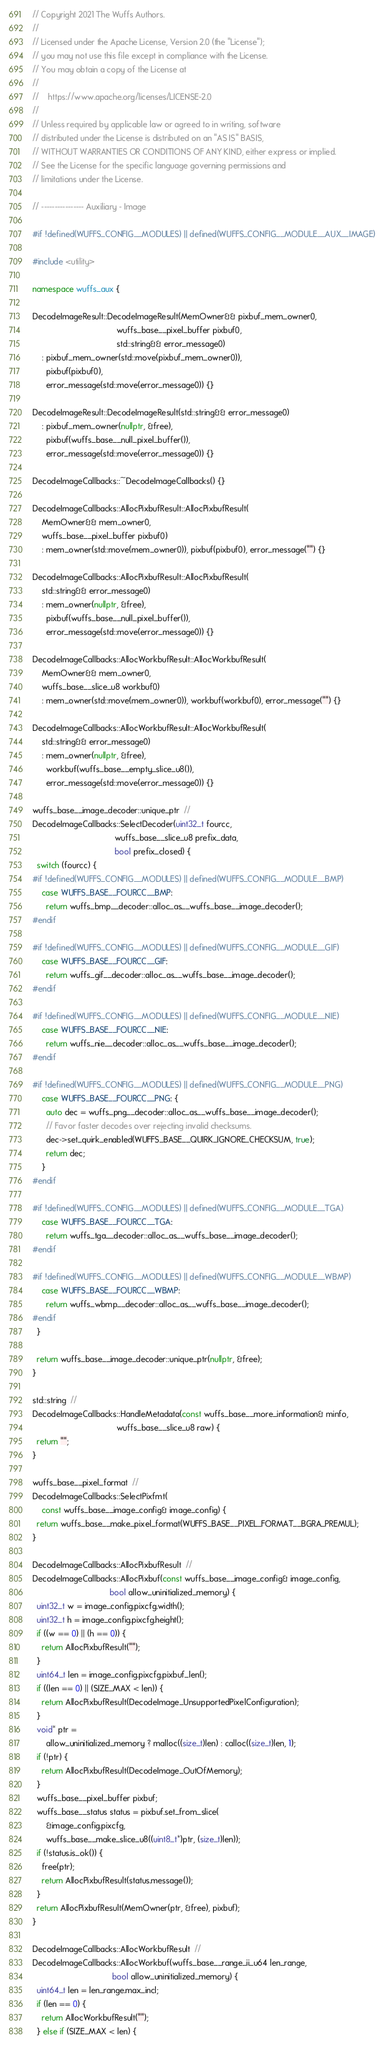<code> <loc_0><loc_0><loc_500><loc_500><_C++_>// Copyright 2021 The Wuffs Authors.
//
// Licensed under the Apache License, Version 2.0 (the "License");
// you may not use this file except in compliance with the License.
// You may obtain a copy of the License at
//
//    https://www.apache.org/licenses/LICENSE-2.0
//
// Unless required by applicable law or agreed to in writing, software
// distributed under the License is distributed on an "AS IS" BASIS,
// WITHOUT WARRANTIES OR CONDITIONS OF ANY KIND, either express or implied.
// See the License for the specific language governing permissions and
// limitations under the License.

// ---------------- Auxiliary - Image

#if !defined(WUFFS_CONFIG__MODULES) || defined(WUFFS_CONFIG__MODULE__AUX__IMAGE)

#include <utility>

namespace wuffs_aux {

DecodeImageResult::DecodeImageResult(MemOwner&& pixbuf_mem_owner0,
                                     wuffs_base__pixel_buffer pixbuf0,
                                     std::string&& error_message0)
    : pixbuf_mem_owner(std::move(pixbuf_mem_owner0)),
      pixbuf(pixbuf0),
      error_message(std::move(error_message0)) {}

DecodeImageResult::DecodeImageResult(std::string&& error_message0)
    : pixbuf_mem_owner(nullptr, &free),
      pixbuf(wuffs_base__null_pixel_buffer()),
      error_message(std::move(error_message0)) {}

DecodeImageCallbacks::~DecodeImageCallbacks() {}

DecodeImageCallbacks::AllocPixbufResult::AllocPixbufResult(
    MemOwner&& mem_owner0,
    wuffs_base__pixel_buffer pixbuf0)
    : mem_owner(std::move(mem_owner0)), pixbuf(pixbuf0), error_message("") {}

DecodeImageCallbacks::AllocPixbufResult::AllocPixbufResult(
    std::string&& error_message0)
    : mem_owner(nullptr, &free),
      pixbuf(wuffs_base__null_pixel_buffer()),
      error_message(std::move(error_message0)) {}

DecodeImageCallbacks::AllocWorkbufResult::AllocWorkbufResult(
    MemOwner&& mem_owner0,
    wuffs_base__slice_u8 workbuf0)
    : mem_owner(std::move(mem_owner0)), workbuf(workbuf0), error_message("") {}

DecodeImageCallbacks::AllocWorkbufResult::AllocWorkbufResult(
    std::string&& error_message0)
    : mem_owner(nullptr, &free),
      workbuf(wuffs_base__empty_slice_u8()),
      error_message(std::move(error_message0)) {}

wuffs_base__image_decoder::unique_ptr  //
DecodeImageCallbacks::SelectDecoder(uint32_t fourcc,
                                    wuffs_base__slice_u8 prefix_data,
                                    bool prefix_closed) {
  switch (fourcc) {
#if !defined(WUFFS_CONFIG__MODULES) || defined(WUFFS_CONFIG__MODULE__BMP)
    case WUFFS_BASE__FOURCC__BMP:
      return wuffs_bmp__decoder::alloc_as__wuffs_base__image_decoder();
#endif

#if !defined(WUFFS_CONFIG__MODULES) || defined(WUFFS_CONFIG__MODULE__GIF)
    case WUFFS_BASE__FOURCC__GIF:
      return wuffs_gif__decoder::alloc_as__wuffs_base__image_decoder();
#endif

#if !defined(WUFFS_CONFIG__MODULES) || defined(WUFFS_CONFIG__MODULE__NIE)
    case WUFFS_BASE__FOURCC__NIE:
      return wuffs_nie__decoder::alloc_as__wuffs_base__image_decoder();
#endif

#if !defined(WUFFS_CONFIG__MODULES) || defined(WUFFS_CONFIG__MODULE__PNG)
    case WUFFS_BASE__FOURCC__PNG: {
      auto dec = wuffs_png__decoder::alloc_as__wuffs_base__image_decoder();
      // Favor faster decodes over rejecting invalid checksums.
      dec->set_quirk_enabled(WUFFS_BASE__QUIRK_IGNORE_CHECKSUM, true);
      return dec;
    }
#endif

#if !defined(WUFFS_CONFIG__MODULES) || defined(WUFFS_CONFIG__MODULE__TGA)
    case WUFFS_BASE__FOURCC__TGA:
      return wuffs_tga__decoder::alloc_as__wuffs_base__image_decoder();
#endif

#if !defined(WUFFS_CONFIG__MODULES) || defined(WUFFS_CONFIG__MODULE__WBMP)
    case WUFFS_BASE__FOURCC__WBMP:
      return wuffs_wbmp__decoder::alloc_as__wuffs_base__image_decoder();
#endif
  }

  return wuffs_base__image_decoder::unique_ptr(nullptr, &free);
}

std::string  //
DecodeImageCallbacks::HandleMetadata(const wuffs_base__more_information& minfo,
                                     wuffs_base__slice_u8 raw) {
  return "";
}

wuffs_base__pixel_format  //
DecodeImageCallbacks::SelectPixfmt(
    const wuffs_base__image_config& image_config) {
  return wuffs_base__make_pixel_format(WUFFS_BASE__PIXEL_FORMAT__BGRA_PREMUL);
}

DecodeImageCallbacks::AllocPixbufResult  //
DecodeImageCallbacks::AllocPixbuf(const wuffs_base__image_config& image_config,
                                  bool allow_uninitialized_memory) {
  uint32_t w = image_config.pixcfg.width();
  uint32_t h = image_config.pixcfg.height();
  if ((w == 0) || (h == 0)) {
    return AllocPixbufResult("");
  }
  uint64_t len = image_config.pixcfg.pixbuf_len();
  if ((len == 0) || (SIZE_MAX < len)) {
    return AllocPixbufResult(DecodeImage_UnsupportedPixelConfiguration);
  }
  void* ptr =
      allow_uninitialized_memory ? malloc((size_t)len) : calloc((size_t)len, 1);
  if (!ptr) {
    return AllocPixbufResult(DecodeImage_OutOfMemory);
  }
  wuffs_base__pixel_buffer pixbuf;
  wuffs_base__status status = pixbuf.set_from_slice(
      &image_config.pixcfg,
      wuffs_base__make_slice_u8((uint8_t*)ptr, (size_t)len));
  if (!status.is_ok()) {
    free(ptr);
    return AllocPixbufResult(status.message());
  }
  return AllocPixbufResult(MemOwner(ptr, &free), pixbuf);
}

DecodeImageCallbacks::AllocWorkbufResult  //
DecodeImageCallbacks::AllocWorkbuf(wuffs_base__range_ii_u64 len_range,
                                   bool allow_uninitialized_memory) {
  uint64_t len = len_range.max_incl;
  if (len == 0) {
    return AllocWorkbufResult("");
  } else if (SIZE_MAX < len) {</code> 